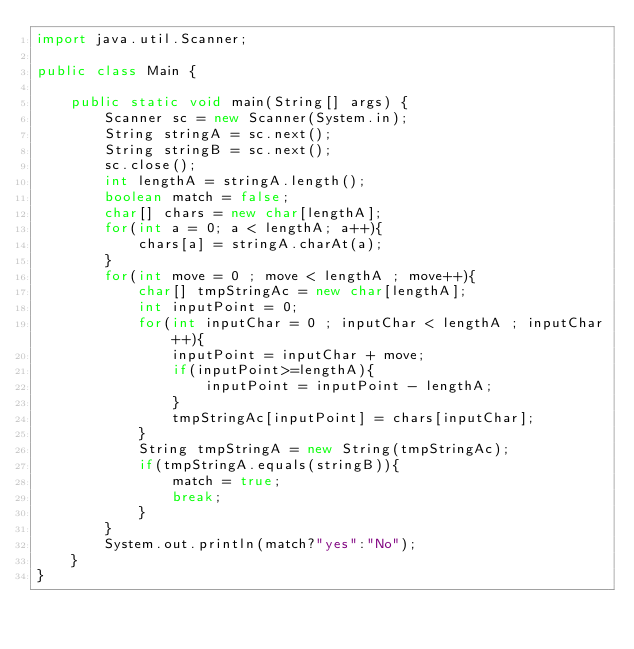<code> <loc_0><loc_0><loc_500><loc_500><_Java_>import java.util.Scanner;

public class Main {

	public static void main(String[] args) {
		Scanner sc = new Scanner(System.in);
		String stringA = sc.next();
		String stringB = sc.next();
		sc.close();
		int lengthA = stringA.length();	
		boolean match = false;
		char[] chars = new char[lengthA];
		for(int a = 0; a < lengthA; a++){
			chars[a] = stringA.charAt(a);
		}
		for(int move = 0 ; move < lengthA ; move++){
			char[] tmpStringAc = new char[lengthA];
			int inputPoint = 0;
			for(int inputChar = 0 ; inputChar < lengthA ; inputChar++){
				inputPoint = inputChar + move;
				if(inputPoint>=lengthA){
					inputPoint = inputPoint - lengthA;
				}
				tmpStringAc[inputPoint] = chars[inputChar];
			}
			String tmpStringA = new String(tmpStringAc);
			if(tmpStringA.equals(stringB)){
				match = true;
				break;
			}
		}
		System.out.println(match?"yes":"No");
	}
}</code> 